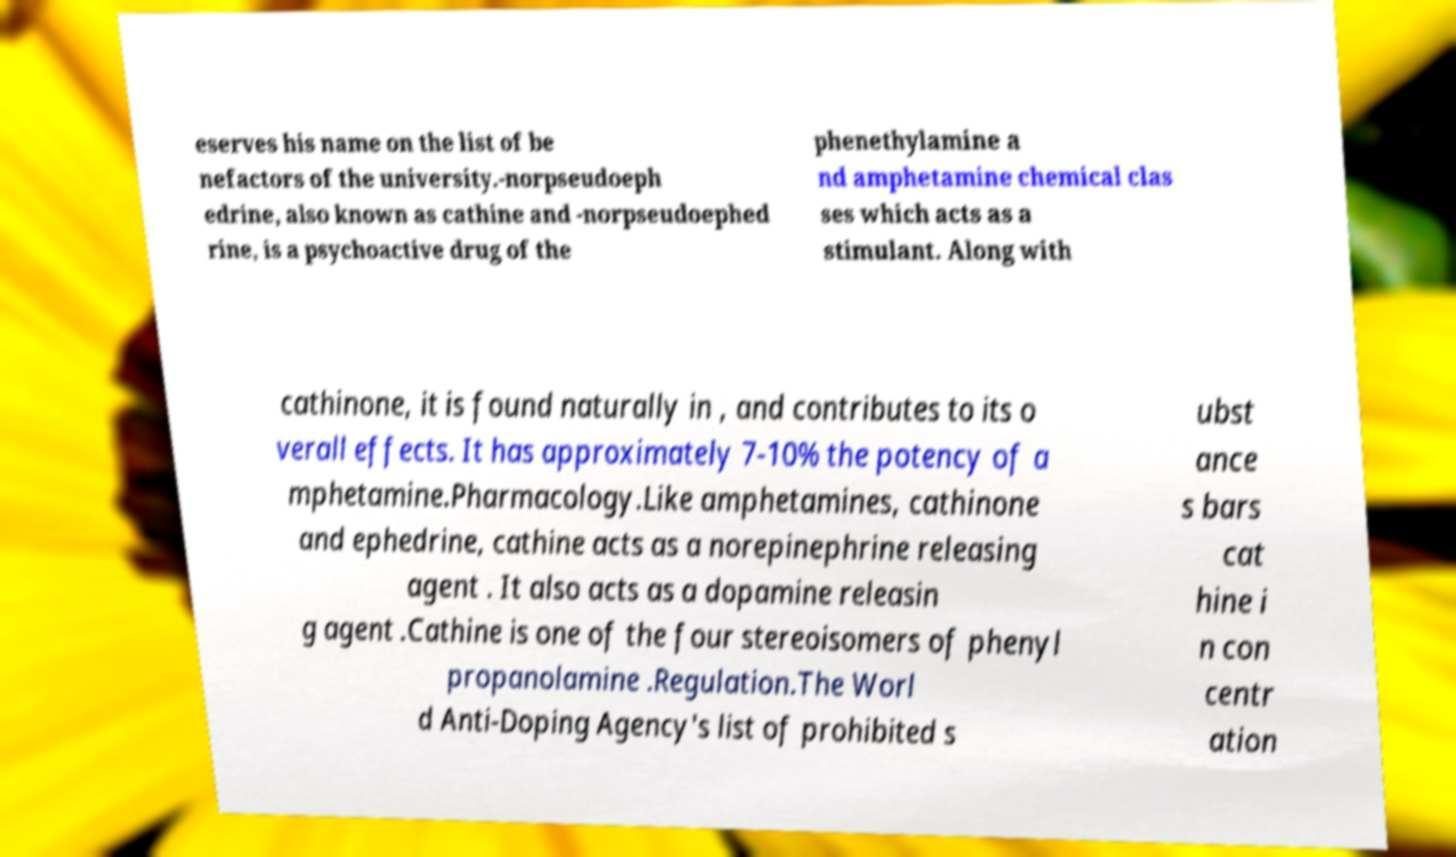Could you extract and type out the text from this image? eserves his name on the list of be nefactors of the university.-norpseudoeph edrine, also known as cathine and -norpseudoephed rine, is a psychoactive drug of the phenethylamine a nd amphetamine chemical clas ses which acts as a stimulant. Along with cathinone, it is found naturally in , and contributes to its o verall effects. It has approximately 7-10% the potency of a mphetamine.Pharmacology.Like amphetamines, cathinone and ephedrine, cathine acts as a norepinephrine releasing agent . It also acts as a dopamine releasin g agent .Cathine is one of the four stereoisomers of phenyl propanolamine .Regulation.The Worl d Anti-Doping Agency's list of prohibited s ubst ance s bars cat hine i n con centr ation 